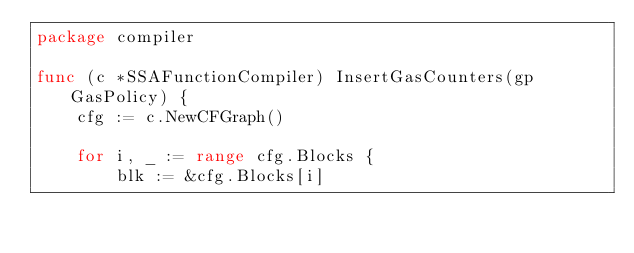Convert code to text. <code><loc_0><loc_0><loc_500><loc_500><_Go_>package compiler

func (c *SSAFunctionCompiler) InsertGasCounters(gp GasPolicy) {
	cfg := c.NewCFGraph()

	for i, _ := range cfg.Blocks {
		blk := &cfg.Blocks[i]</code> 